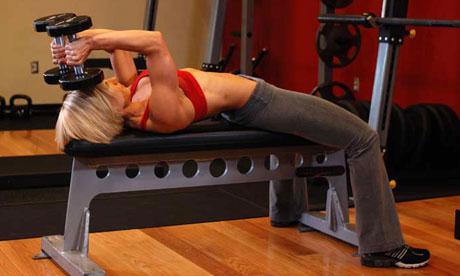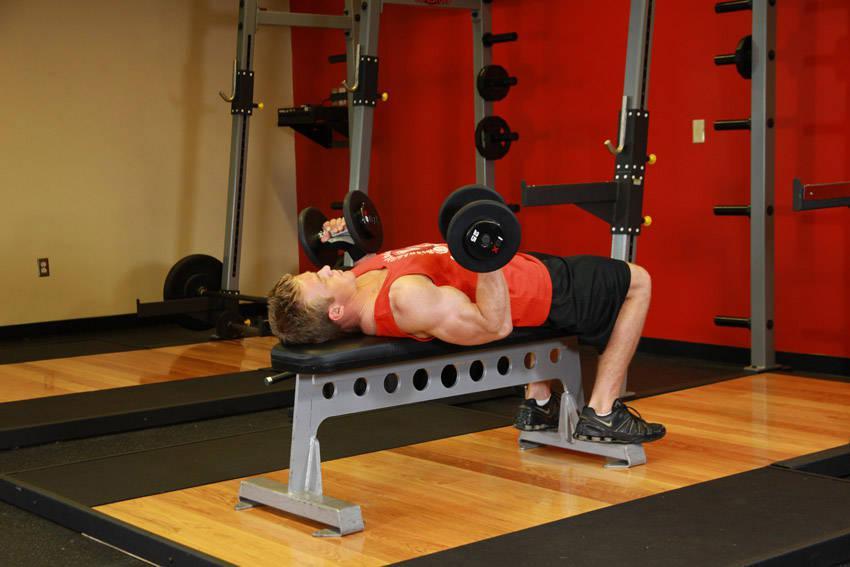The first image is the image on the left, the second image is the image on the right. Examine the images to the left and right. Is the description "There is a man dressed in black shorts and a red shirt in one of the images" accurate? Answer yes or no. Yes. 